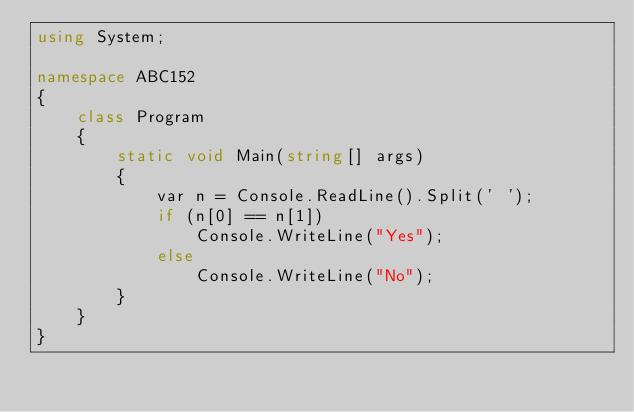<code> <loc_0><loc_0><loc_500><loc_500><_C#_>using System;

namespace ABC152
{
    class Program
    {
        static void Main(string[] args)
        {
            var n = Console.ReadLine().Split(' ');
            if (n[0] == n[1])
                Console.WriteLine("Yes");
            else
                Console.WriteLine("No");
        }
    }
}</code> 